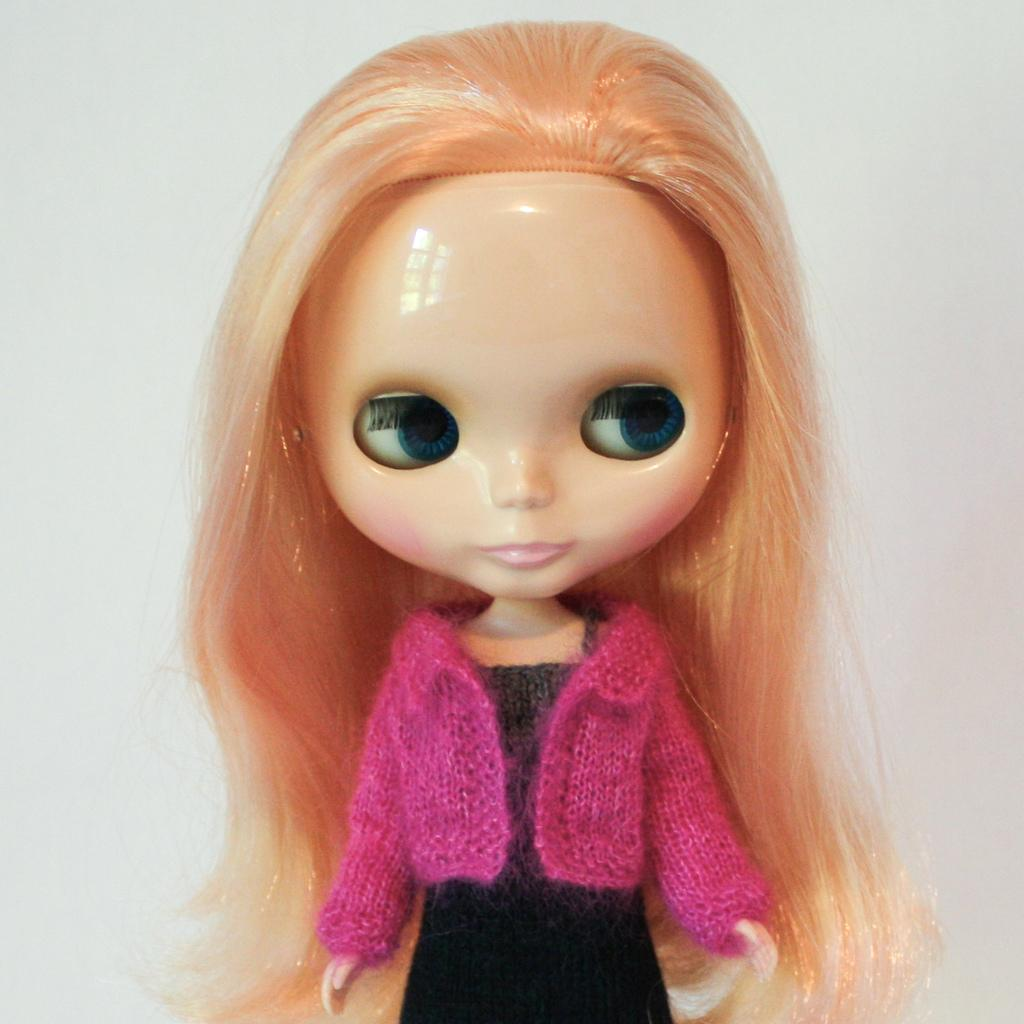What is the main subject of the image? There is a doll in the image. What color is the background of the image? The background of the image is white. Can you see any cables in the image? There are no cables visible in the image. What type of ocean can be seen in the background of the image? There is no ocean present in the image; the background is white. 